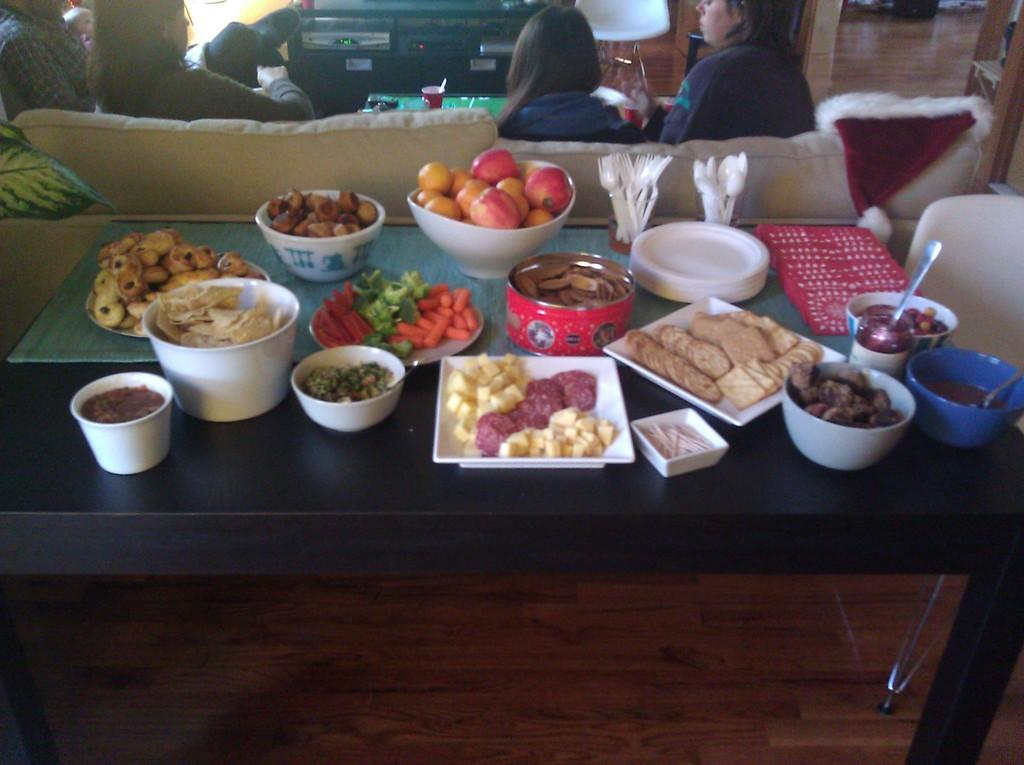What type of tableware can be seen on the table in the image? There are bowls, plates, spoons, and forks on the table in the image. What is covering the table? There is a cloth on the table. What is present on the table that indicates a meal is being served? There is food on the table. What part of the room is visible in the image? The floor is visible in the image. Can you describe the seating arrangement in the background? There are four persons sitting on a couch in the background. What type of pump is being used to irrigate the goat in the image? There is no pump or goat present in the image; it features a table with tableware, food, and a cloth, as well as a couch with people in the background. 